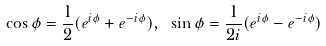<formula> <loc_0><loc_0><loc_500><loc_500>\cos \phi = \frac { 1 } { 2 } ( e ^ { i \phi } + e ^ { - i \phi } ) , \ \sin \phi = \frac { 1 } { 2 i } ( e ^ { i \phi } - e ^ { - i \phi } )</formula> 